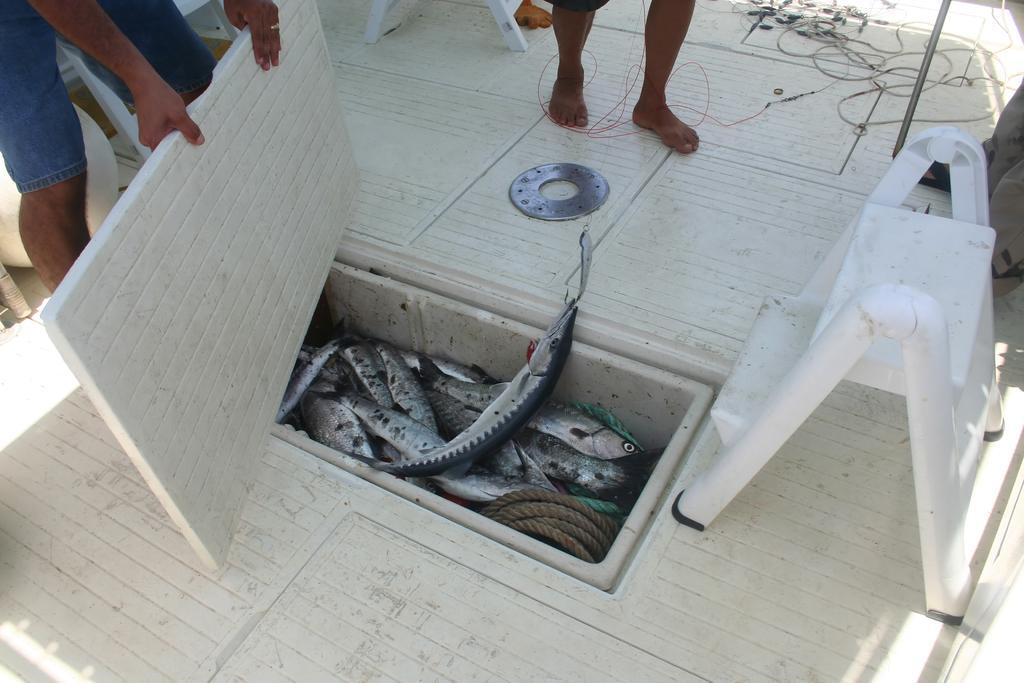How would you summarize this image in a sentence or two? In this image I can see the fish which are in silver color. To the side I can see the rope. To the side of the fish I can see two people. One person is holding the white color board. To the right I can see the ladder which is in white color. 